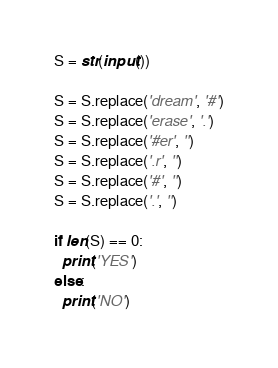Convert code to text. <code><loc_0><loc_0><loc_500><loc_500><_Python_>S = str(input())

S = S.replace('dream', '#')
S = S.replace('erase', '.')
S = S.replace('#er', '')
S = S.replace('.r', '')
S = S.replace('#', '')
S = S.replace('.', '')

if len(S) == 0:
  print('YES')
else:
  print('NO')
</code> 